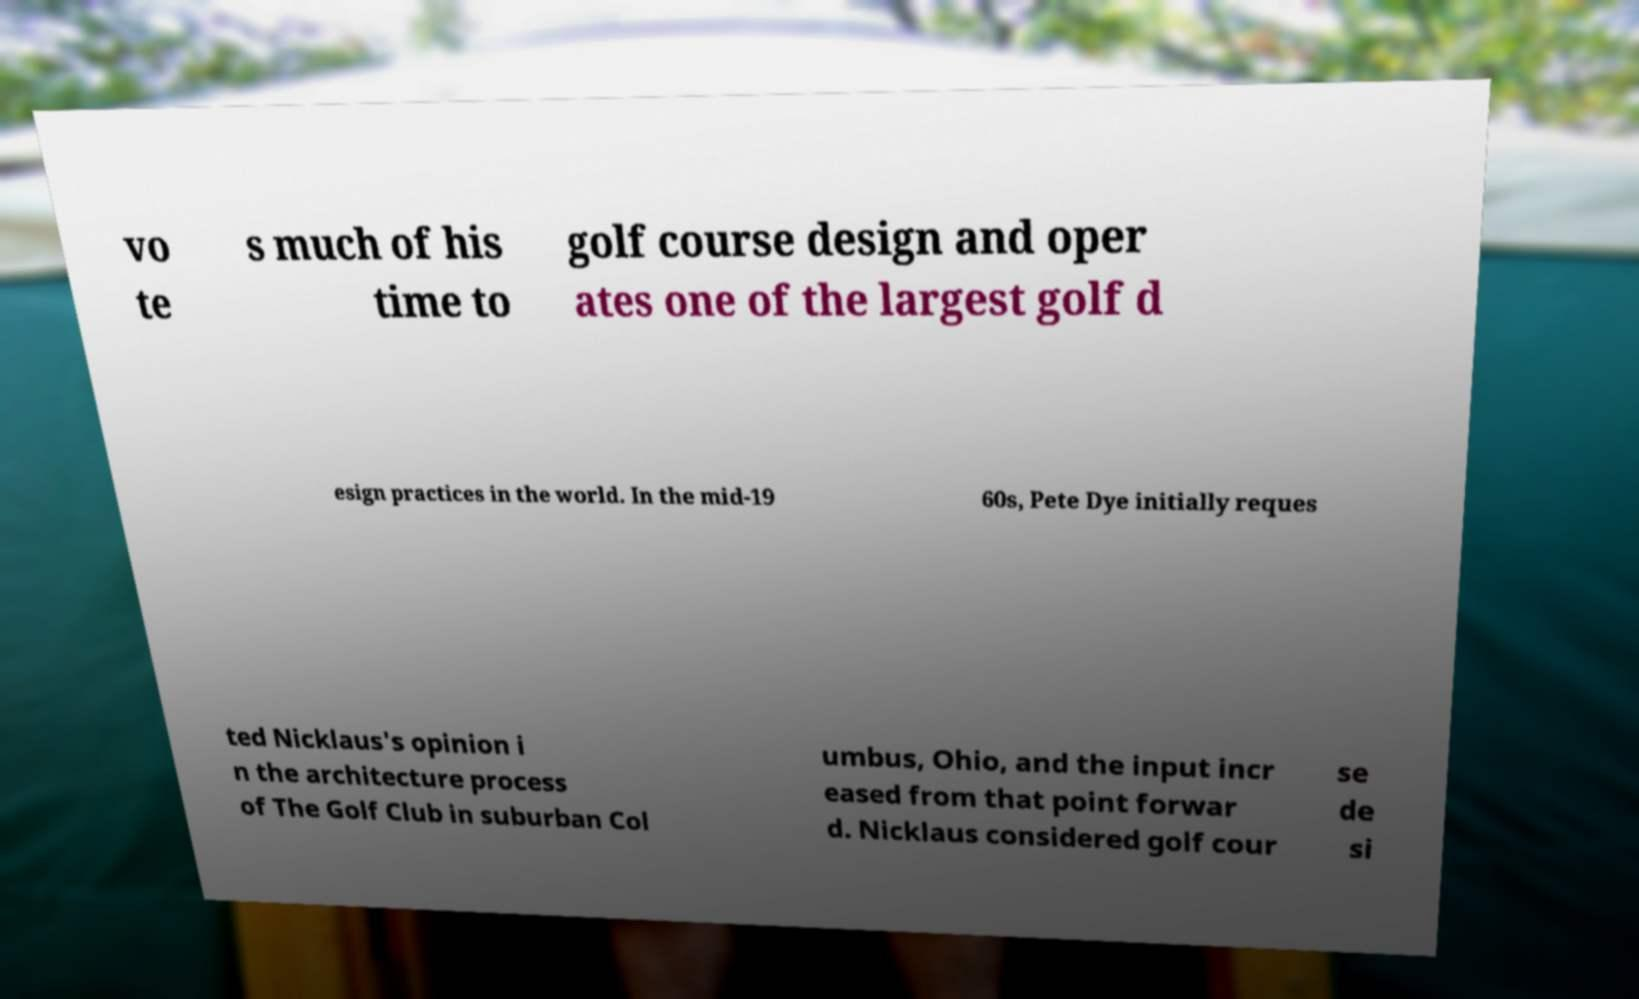What messages or text are displayed in this image? I need them in a readable, typed format. vo te s much of his time to golf course design and oper ates one of the largest golf d esign practices in the world. In the mid-19 60s, Pete Dye initially reques ted Nicklaus's opinion i n the architecture process of The Golf Club in suburban Col umbus, Ohio, and the input incr eased from that point forwar d. Nicklaus considered golf cour se de si 